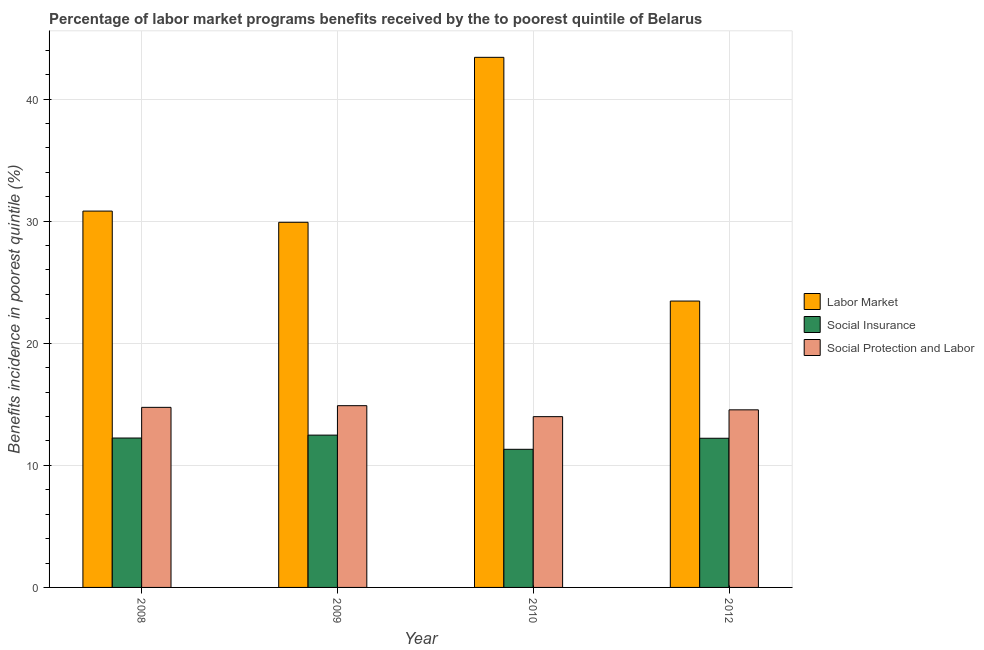Are the number of bars on each tick of the X-axis equal?
Offer a very short reply. Yes. How many bars are there on the 2nd tick from the right?
Provide a short and direct response. 3. What is the percentage of benefits received due to labor market programs in 2009?
Keep it short and to the point. 29.9. Across all years, what is the maximum percentage of benefits received due to social insurance programs?
Your answer should be very brief. 12.47. Across all years, what is the minimum percentage of benefits received due to social insurance programs?
Your response must be concise. 11.31. In which year was the percentage of benefits received due to social insurance programs maximum?
Ensure brevity in your answer.  2009. What is the total percentage of benefits received due to social protection programs in the graph?
Offer a very short reply. 58.16. What is the difference between the percentage of benefits received due to labor market programs in 2008 and that in 2012?
Offer a terse response. 7.37. What is the difference between the percentage of benefits received due to labor market programs in 2008 and the percentage of benefits received due to social insurance programs in 2009?
Your answer should be compact. 0.92. What is the average percentage of benefits received due to labor market programs per year?
Your response must be concise. 31.9. In the year 2012, what is the difference between the percentage of benefits received due to labor market programs and percentage of benefits received due to social insurance programs?
Your response must be concise. 0. In how many years, is the percentage of benefits received due to social protection programs greater than 16 %?
Provide a short and direct response. 0. What is the ratio of the percentage of benefits received due to labor market programs in 2008 to that in 2010?
Ensure brevity in your answer.  0.71. Is the percentage of benefits received due to social insurance programs in 2009 less than that in 2010?
Ensure brevity in your answer.  No. Is the difference between the percentage of benefits received due to social insurance programs in 2008 and 2012 greater than the difference between the percentage of benefits received due to labor market programs in 2008 and 2012?
Your answer should be very brief. No. What is the difference between the highest and the second highest percentage of benefits received due to social insurance programs?
Give a very brief answer. 0.24. What is the difference between the highest and the lowest percentage of benefits received due to social insurance programs?
Provide a succinct answer. 1.16. Is the sum of the percentage of benefits received due to social protection programs in 2010 and 2012 greater than the maximum percentage of benefits received due to labor market programs across all years?
Give a very brief answer. Yes. What does the 2nd bar from the left in 2008 represents?
Keep it short and to the point. Social Insurance. What does the 3rd bar from the right in 2009 represents?
Keep it short and to the point. Labor Market. Is it the case that in every year, the sum of the percentage of benefits received due to labor market programs and percentage of benefits received due to social insurance programs is greater than the percentage of benefits received due to social protection programs?
Offer a terse response. Yes. How many bars are there?
Offer a very short reply. 12. How many years are there in the graph?
Ensure brevity in your answer.  4. Are the values on the major ticks of Y-axis written in scientific E-notation?
Make the answer very short. No. Does the graph contain any zero values?
Make the answer very short. No. How many legend labels are there?
Make the answer very short. 3. What is the title of the graph?
Your answer should be compact. Percentage of labor market programs benefits received by the to poorest quintile of Belarus. Does "Textiles and clothing" appear as one of the legend labels in the graph?
Provide a succinct answer. No. What is the label or title of the X-axis?
Ensure brevity in your answer.  Year. What is the label or title of the Y-axis?
Your answer should be compact. Benefits incidence in poorest quintile (%). What is the Benefits incidence in poorest quintile (%) in Labor Market in 2008?
Your answer should be compact. 30.82. What is the Benefits incidence in poorest quintile (%) in Social Insurance in 2008?
Keep it short and to the point. 12.24. What is the Benefits incidence in poorest quintile (%) of Social Protection and Labor in 2008?
Provide a short and direct response. 14.75. What is the Benefits incidence in poorest quintile (%) of Labor Market in 2009?
Give a very brief answer. 29.9. What is the Benefits incidence in poorest quintile (%) of Social Insurance in 2009?
Provide a short and direct response. 12.47. What is the Benefits incidence in poorest quintile (%) in Social Protection and Labor in 2009?
Offer a very short reply. 14.89. What is the Benefits incidence in poorest quintile (%) in Labor Market in 2010?
Your answer should be compact. 43.42. What is the Benefits incidence in poorest quintile (%) of Social Insurance in 2010?
Your answer should be compact. 11.31. What is the Benefits incidence in poorest quintile (%) in Social Protection and Labor in 2010?
Make the answer very short. 13.99. What is the Benefits incidence in poorest quintile (%) of Labor Market in 2012?
Keep it short and to the point. 23.45. What is the Benefits incidence in poorest quintile (%) of Social Insurance in 2012?
Provide a succinct answer. 12.22. What is the Benefits incidence in poorest quintile (%) in Social Protection and Labor in 2012?
Keep it short and to the point. 14.54. Across all years, what is the maximum Benefits incidence in poorest quintile (%) of Labor Market?
Provide a succinct answer. 43.42. Across all years, what is the maximum Benefits incidence in poorest quintile (%) of Social Insurance?
Your response must be concise. 12.47. Across all years, what is the maximum Benefits incidence in poorest quintile (%) in Social Protection and Labor?
Ensure brevity in your answer.  14.89. Across all years, what is the minimum Benefits incidence in poorest quintile (%) in Labor Market?
Offer a very short reply. 23.45. Across all years, what is the minimum Benefits incidence in poorest quintile (%) of Social Insurance?
Your response must be concise. 11.31. Across all years, what is the minimum Benefits incidence in poorest quintile (%) in Social Protection and Labor?
Ensure brevity in your answer.  13.99. What is the total Benefits incidence in poorest quintile (%) of Labor Market in the graph?
Your response must be concise. 127.6. What is the total Benefits incidence in poorest quintile (%) of Social Insurance in the graph?
Offer a very short reply. 48.24. What is the total Benefits incidence in poorest quintile (%) of Social Protection and Labor in the graph?
Keep it short and to the point. 58.16. What is the difference between the Benefits incidence in poorest quintile (%) of Labor Market in 2008 and that in 2009?
Make the answer very short. 0.92. What is the difference between the Benefits incidence in poorest quintile (%) in Social Insurance in 2008 and that in 2009?
Offer a terse response. -0.24. What is the difference between the Benefits incidence in poorest quintile (%) of Social Protection and Labor in 2008 and that in 2009?
Make the answer very short. -0.14. What is the difference between the Benefits incidence in poorest quintile (%) in Labor Market in 2008 and that in 2010?
Keep it short and to the point. -12.59. What is the difference between the Benefits incidence in poorest quintile (%) of Social Insurance in 2008 and that in 2010?
Offer a very short reply. 0.92. What is the difference between the Benefits incidence in poorest quintile (%) of Social Protection and Labor in 2008 and that in 2010?
Offer a very short reply. 0.76. What is the difference between the Benefits incidence in poorest quintile (%) of Labor Market in 2008 and that in 2012?
Make the answer very short. 7.37. What is the difference between the Benefits incidence in poorest quintile (%) of Social Insurance in 2008 and that in 2012?
Offer a very short reply. 0.02. What is the difference between the Benefits incidence in poorest quintile (%) in Social Protection and Labor in 2008 and that in 2012?
Your answer should be very brief. 0.2. What is the difference between the Benefits incidence in poorest quintile (%) of Labor Market in 2009 and that in 2010?
Provide a short and direct response. -13.51. What is the difference between the Benefits incidence in poorest quintile (%) in Social Insurance in 2009 and that in 2010?
Ensure brevity in your answer.  1.16. What is the difference between the Benefits incidence in poorest quintile (%) of Social Protection and Labor in 2009 and that in 2010?
Ensure brevity in your answer.  0.9. What is the difference between the Benefits incidence in poorest quintile (%) of Labor Market in 2009 and that in 2012?
Provide a succinct answer. 6.45. What is the difference between the Benefits incidence in poorest quintile (%) of Social Insurance in 2009 and that in 2012?
Offer a very short reply. 0.26. What is the difference between the Benefits incidence in poorest quintile (%) in Social Protection and Labor in 2009 and that in 2012?
Your answer should be very brief. 0.34. What is the difference between the Benefits incidence in poorest quintile (%) of Labor Market in 2010 and that in 2012?
Ensure brevity in your answer.  19.96. What is the difference between the Benefits incidence in poorest quintile (%) of Social Insurance in 2010 and that in 2012?
Ensure brevity in your answer.  -0.9. What is the difference between the Benefits incidence in poorest quintile (%) of Social Protection and Labor in 2010 and that in 2012?
Keep it short and to the point. -0.56. What is the difference between the Benefits incidence in poorest quintile (%) in Labor Market in 2008 and the Benefits incidence in poorest quintile (%) in Social Insurance in 2009?
Provide a succinct answer. 18.35. What is the difference between the Benefits incidence in poorest quintile (%) of Labor Market in 2008 and the Benefits incidence in poorest quintile (%) of Social Protection and Labor in 2009?
Make the answer very short. 15.94. What is the difference between the Benefits incidence in poorest quintile (%) in Social Insurance in 2008 and the Benefits incidence in poorest quintile (%) in Social Protection and Labor in 2009?
Provide a succinct answer. -2.65. What is the difference between the Benefits incidence in poorest quintile (%) in Labor Market in 2008 and the Benefits incidence in poorest quintile (%) in Social Insurance in 2010?
Your answer should be compact. 19.51. What is the difference between the Benefits incidence in poorest quintile (%) in Labor Market in 2008 and the Benefits incidence in poorest quintile (%) in Social Protection and Labor in 2010?
Give a very brief answer. 16.84. What is the difference between the Benefits incidence in poorest quintile (%) in Social Insurance in 2008 and the Benefits incidence in poorest quintile (%) in Social Protection and Labor in 2010?
Your response must be concise. -1.75. What is the difference between the Benefits incidence in poorest quintile (%) of Labor Market in 2008 and the Benefits incidence in poorest quintile (%) of Social Insurance in 2012?
Your answer should be very brief. 18.61. What is the difference between the Benefits incidence in poorest quintile (%) of Labor Market in 2008 and the Benefits incidence in poorest quintile (%) of Social Protection and Labor in 2012?
Offer a terse response. 16.28. What is the difference between the Benefits incidence in poorest quintile (%) of Social Insurance in 2008 and the Benefits incidence in poorest quintile (%) of Social Protection and Labor in 2012?
Give a very brief answer. -2.31. What is the difference between the Benefits incidence in poorest quintile (%) in Labor Market in 2009 and the Benefits incidence in poorest quintile (%) in Social Insurance in 2010?
Your answer should be very brief. 18.59. What is the difference between the Benefits incidence in poorest quintile (%) of Labor Market in 2009 and the Benefits incidence in poorest quintile (%) of Social Protection and Labor in 2010?
Keep it short and to the point. 15.92. What is the difference between the Benefits incidence in poorest quintile (%) of Social Insurance in 2009 and the Benefits incidence in poorest quintile (%) of Social Protection and Labor in 2010?
Your answer should be very brief. -1.51. What is the difference between the Benefits incidence in poorest quintile (%) in Labor Market in 2009 and the Benefits incidence in poorest quintile (%) in Social Insurance in 2012?
Provide a succinct answer. 17.69. What is the difference between the Benefits incidence in poorest quintile (%) of Labor Market in 2009 and the Benefits incidence in poorest quintile (%) of Social Protection and Labor in 2012?
Make the answer very short. 15.36. What is the difference between the Benefits incidence in poorest quintile (%) of Social Insurance in 2009 and the Benefits incidence in poorest quintile (%) of Social Protection and Labor in 2012?
Your answer should be compact. -2.07. What is the difference between the Benefits incidence in poorest quintile (%) of Labor Market in 2010 and the Benefits incidence in poorest quintile (%) of Social Insurance in 2012?
Provide a succinct answer. 31.2. What is the difference between the Benefits incidence in poorest quintile (%) of Labor Market in 2010 and the Benefits incidence in poorest quintile (%) of Social Protection and Labor in 2012?
Provide a short and direct response. 28.87. What is the difference between the Benefits incidence in poorest quintile (%) in Social Insurance in 2010 and the Benefits incidence in poorest quintile (%) in Social Protection and Labor in 2012?
Ensure brevity in your answer.  -3.23. What is the average Benefits incidence in poorest quintile (%) of Labor Market per year?
Your answer should be very brief. 31.9. What is the average Benefits incidence in poorest quintile (%) in Social Insurance per year?
Your answer should be compact. 12.06. What is the average Benefits incidence in poorest quintile (%) of Social Protection and Labor per year?
Offer a terse response. 14.54. In the year 2008, what is the difference between the Benefits incidence in poorest quintile (%) in Labor Market and Benefits incidence in poorest quintile (%) in Social Insurance?
Keep it short and to the point. 18.59. In the year 2008, what is the difference between the Benefits incidence in poorest quintile (%) in Labor Market and Benefits incidence in poorest quintile (%) in Social Protection and Labor?
Your answer should be very brief. 16.07. In the year 2008, what is the difference between the Benefits incidence in poorest quintile (%) of Social Insurance and Benefits incidence in poorest quintile (%) of Social Protection and Labor?
Your answer should be very brief. -2.51. In the year 2009, what is the difference between the Benefits incidence in poorest quintile (%) in Labor Market and Benefits incidence in poorest quintile (%) in Social Insurance?
Provide a succinct answer. 17.43. In the year 2009, what is the difference between the Benefits incidence in poorest quintile (%) in Labor Market and Benefits incidence in poorest quintile (%) in Social Protection and Labor?
Provide a succinct answer. 15.02. In the year 2009, what is the difference between the Benefits incidence in poorest quintile (%) in Social Insurance and Benefits incidence in poorest quintile (%) in Social Protection and Labor?
Your response must be concise. -2.41. In the year 2010, what is the difference between the Benefits incidence in poorest quintile (%) in Labor Market and Benefits incidence in poorest quintile (%) in Social Insurance?
Offer a very short reply. 32.1. In the year 2010, what is the difference between the Benefits incidence in poorest quintile (%) of Labor Market and Benefits incidence in poorest quintile (%) of Social Protection and Labor?
Offer a very short reply. 29.43. In the year 2010, what is the difference between the Benefits incidence in poorest quintile (%) in Social Insurance and Benefits incidence in poorest quintile (%) in Social Protection and Labor?
Give a very brief answer. -2.67. In the year 2012, what is the difference between the Benefits incidence in poorest quintile (%) of Labor Market and Benefits incidence in poorest quintile (%) of Social Insurance?
Give a very brief answer. 11.24. In the year 2012, what is the difference between the Benefits incidence in poorest quintile (%) of Labor Market and Benefits incidence in poorest quintile (%) of Social Protection and Labor?
Ensure brevity in your answer.  8.91. In the year 2012, what is the difference between the Benefits incidence in poorest quintile (%) of Social Insurance and Benefits incidence in poorest quintile (%) of Social Protection and Labor?
Offer a very short reply. -2.33. What is the ratio of the Benefits incidence in poorest quintile (%) in Labor Market in 2008 to that in 2009?
Give a very brief answer. 1.03. What is the ratio of the Benefits incidence in poorest quintile (%) in Social Insurance in 2008 to that in 2009?
Give a very brief answer. 0.98. What is the ratio of the Benefits incidence in poorest quintile (%) of Labor Market in 2008 to that in 2010?
Offer a terse response. 0.71. What is the ratio of the Benefits incidence in poorest quintile (%) in Social Insurance in 2008 to that in 2010?
Keep it short and to the point. 1.08. What is the ratio of the Benefits incidence in poorest quintile (%) in Social Protection and Labor in 2008 to that in 2010?
Make the answer very short. 1.05. What is the ratio of the Benefits incidence in poorest quintile (%) of Labor Market in 2008 to that in 2012?
Provide a succinct answer. 1.31. What is the ratio of the Benefits incidence in poorest quintile (%) of Social Protection and Labor in 2008 to that in 2012?
Provide a succinct answer. 1.01. What is the ratio of the Benefits incidence in poorest quintile (%) in Labor Market in 2009 to that in 2010?
Ensure brevity in your answer.  0.69. What is the ratio of the Benefits incidence in poorest quintile (%) in Social Insurance in 2009 to that in 2010?
Provide a succinct answer. 1.1. What is the ratio of the Benefits incidence in poorest quintile (%) of Social Protection and Labor in 2009 to that in 2010?
Provide a short and direct response. 1.06. What is the ratio of the Benefits incidence in poorest quintile (%) of Labor Market in 2009 to that in 2012?
Offer a terse response. 1.27. What is the ratio of the Benefits incidence in poorest quintile (%) in Social Protection and Labor in 2009 to that in 2012?
Provide a short and direct response. 1.02. What is the ratio of the Benefits incidence in poorest quintile (%) of Labor Market in 2010 to that in 2012?
Your answer should be very brief. 1.85. What is the ratio of the Benefits incidence in poorest quintile (%) of Social Insurance in 2010 to that in 2012?
Provide a short and direct response. 0.93. What is the ratio of the Benefits incidence in poorest quintile (%) in Social Protection and Labor in 2010 to that in 2012?
Give a very brief answer. 0.96. What is the difference between the highest and the second highest Benefits incidence in poorest quintile (%) in Labor Market?
Your answer should be compact. 12.59. What is the difference between the highest and the second highest Benefits incidence in poorest quintile (%) in Social Insurance?
Provide a succinct answer. 0.24. What is the difference between the highest and the second highest Benefits incidence in poorest quintile (%) in Social Protection and Labor?
Give a very brief answer. 0.14. What is the difference between the highest and the lowest Benefits incidence in poorest quintile (%) of Labor Market?
Keep it short and to the point. 19.96. What is the difference between the highest and the lowest Benefits incidence in poorest quintile (%) in Social Insurance?
Provide a succinct answer. 1.16. What is the difference between the highest and the lowest Benefits incidence in poorest quintile (%) in Social Protection and Labor?
Offer a very short reply. 0.9. 